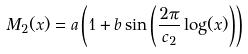<formula> <loc_0><loc_0><loc_500><loc_500>M _ { 2 } ( x ) = a \left ( 1 + b \sin \left ( \frac { 2 \pi } { c _ { 2 } } \log ( x ) \right ) \right )</formula> 